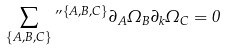Convert formula to latex. <formula><loc_0><loc_0><loc_500><loc_500>\sum _ { \{ A , B , C \} } \varepsilon ^ { \{ A , B , C \} } \partial _ { A } \Omega _ { B } \partial _ { k } \Omega _ { C } = 0</formula> 